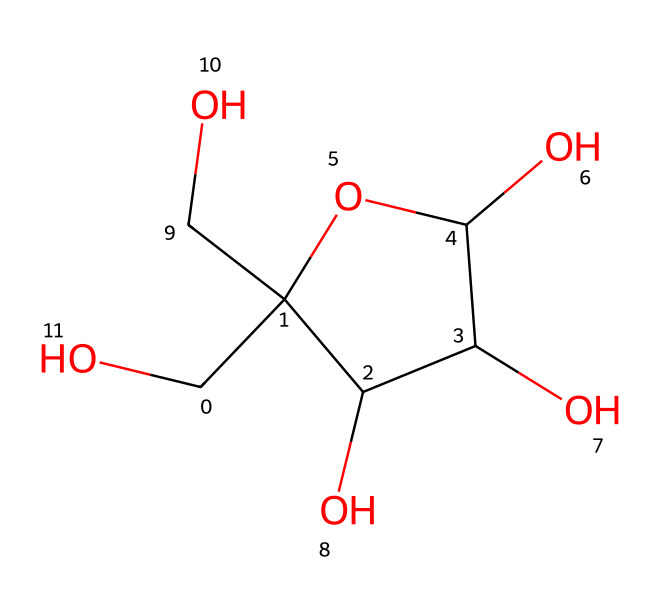What is the molecular formula of this compound? To determine the molecular formula, count the number of carbon (C), hydrogen (H), and oxygen (O) atoms in the structure. The SMILES indicates there are six carbon atoms, twelve hydrogen atoms, and six oxygen atoms. Thus, the molecular formula is C6H12O6.
Answer: C6H12O6 How many chiral centers are present in fructose? A chiral center is identified by a carbon atom that is attached to four different groups. Analyzing the structure, there are three carbon atoms where the substituents are distinct. Hence, fructose has three chiral centers.
Answer: 3 What type of carbohydrate is fructose classified as? Fructose is a simple sugar that can be categorized as a monosaccharide. Monosaccharides are the simplest form of carbohydrates and cannot be hydrolyzed into simpler sugars. In this case, since fructose is a single sugar unit, it is classified as a monosaccharide.
Answer: monosaccharide How does fructose in natural fruit juices compare to artificial sweeteners in sweetness? Fructose is known to be significantly sweeter than glucose and is sweeter than many artificial sweeteners used in food products. This is determined from the comparison of sweetness levels between natural sugars and artificial alternatives.
Answer: sweeter What is the cyclic form of fructose represented here? The structure provided indicates a cyclic form because it includes a ring structure formed by carbon atoms. Fructose predominantly exists in a five-membered ring (furanose form) when in solution. This format supports its classification as a furanose.
Answer: furanose What functional groups are present in fructose? The structural representation of fructose shows multiple hydroxyl (-OH) groups as well as a carbonyl group (C=O). The presence of these functional groups defines its chemical nature and reactivity as an aldose.
Answer: hydroxyl and carbonyl groups 